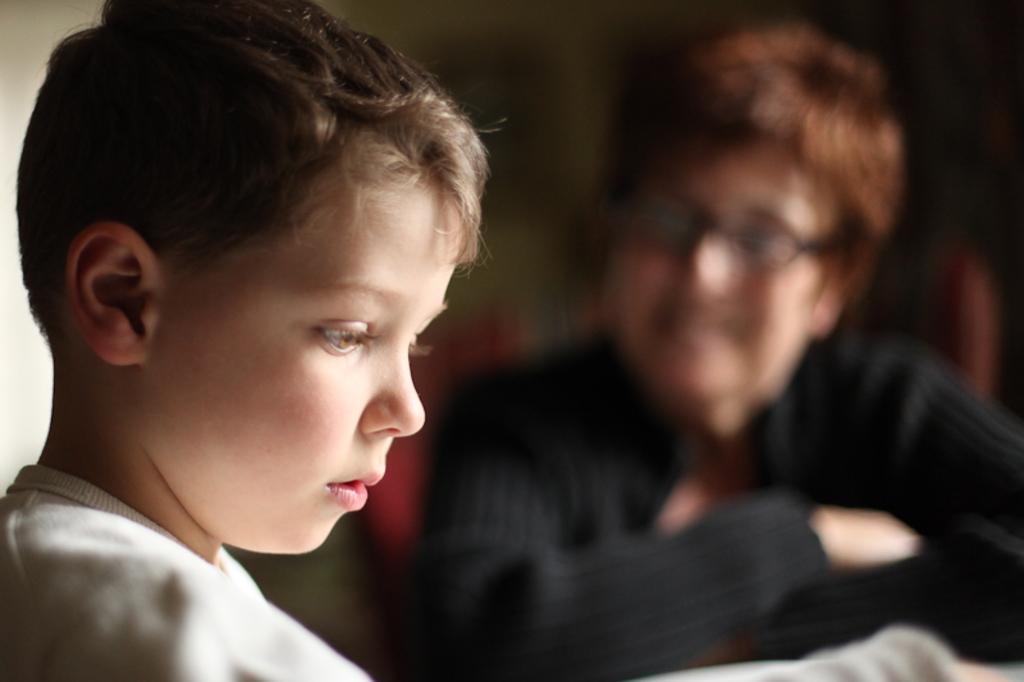Describe this image in one or two sentences. In this picture we can see a boy and a person. Behind the people, there is the blurred background. 